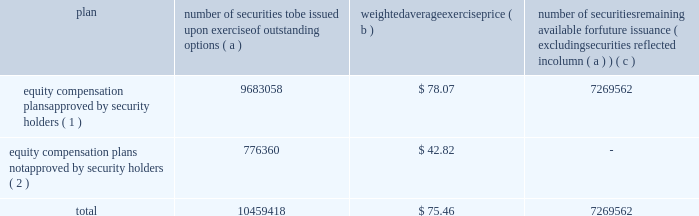Equity compensation plan information the table summarizes the equity compensation plan information as of december 31 , 2011 .
Information is included for equity compensation plans approved by the stockholders and equity compensation plans not approved by the stockholders .
Number of securities to be issued upon exercise of outstanding options weighted average exercise number of securities remaining available for future issuance ( excluding securities reflected in column ( a ) ) equity compensation plans approved by security holders ( 1 ) 9683058 $ 78.07 7269562 equity compensation plans not approved by security holders ( 2 ) 776360 $ 42.82 .
( 1 ) includes the equity ownership plan , which was approved by the shareholders on may 15 , 1998 , the 2007 equity ownership plan and the 2011 equity ownership plan .
The 2007 equity ownership plan was approved by entergy corporation shareholders on may 12 , 2006 , and 7000000 shares of entergy corporation common stock can be issued , with no more than 2000000 shares available for non-option grants .
The 2011 equity ownership plan was approved by entergy corporation shareholders on may 6 , 2011 , and 5500000 shares of entergy corporation common stock can be issued from the 2011 equity ownership plan , with no more than 2000000 shares available for incentive stock option grants .
The equity ownership plan , the 2007 equity ownership plan and the 2011 equity ownership plan ( the 201cplans 201d ) are administered by the personnel committee of the board of directors ( other than with respect to awards granted to non-employee directors , which awards are administered by the entire board of directors ) .
Eligibility under the plans is limited to the non-employee directors and to the officers and employees of an entergy system employer and any corporation 80% ( 80 % ) or more of whose stock ( based on voting power ) or value is owned , directly or indirectly , by entergy corporation .
The plans provide for the issuance of stock options , restricted shares , equity awards ( units whose value is related to the value of shares of the common stock but do not represent actual shares of common stock ) , performance awards ( performance shares or units valued by reference to shares of common stock or performance units valued by reference to financial measures or property other than common stock ) and other stock-based awards .
( 2 ) entergy has a board-approved stock-based compensation plan .
However , effective may 9 , 2003 , the board has directed that no further awards be issued under that plan .
Item 13 .
Certain relationships and related transactions and director independence for information regarding certain relationships , related transactions and director independence of entergy corporation , see the proxy statement under the headings 201ccorporate governance - director independence 201d and 201ctransactions with related persons , 201d which information is incorporated herein by reference .
Since december 31 , 2010 , none of the subsidiaries or any of their affiliates has participated in any transaction involving an amount in excess of $ 120000 in which any director or executive officer of any of the subsidiaries , any nominee for director , or any immediate family member of the foregoing had a material interest as contemplated by item 404 ( a ) of regulation s-k ( 201crelated party transactions 201d ) .
Entergy corporation 2019s board of directors has adopted written policies and procedures for the review , approval or ratification of related party transactions .
Under these policies and procedures , the corporate governance committee , or a subcommittee of the board of directors of entergy corporation composed of .
In 2011 what as the percent of the number of securities to be issued upon exercise of outstanding options authorized by the shareholders? 
Computations: (9683058 / 10459418)
Answer: 0.92577. 